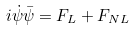Convert formula to latex. <formula><loc_0><loc_0><loc_500><loc_500>i { \dot { \psi } } { \bar { \psi } } = F _ { L } + F _ { N L }</formula> 